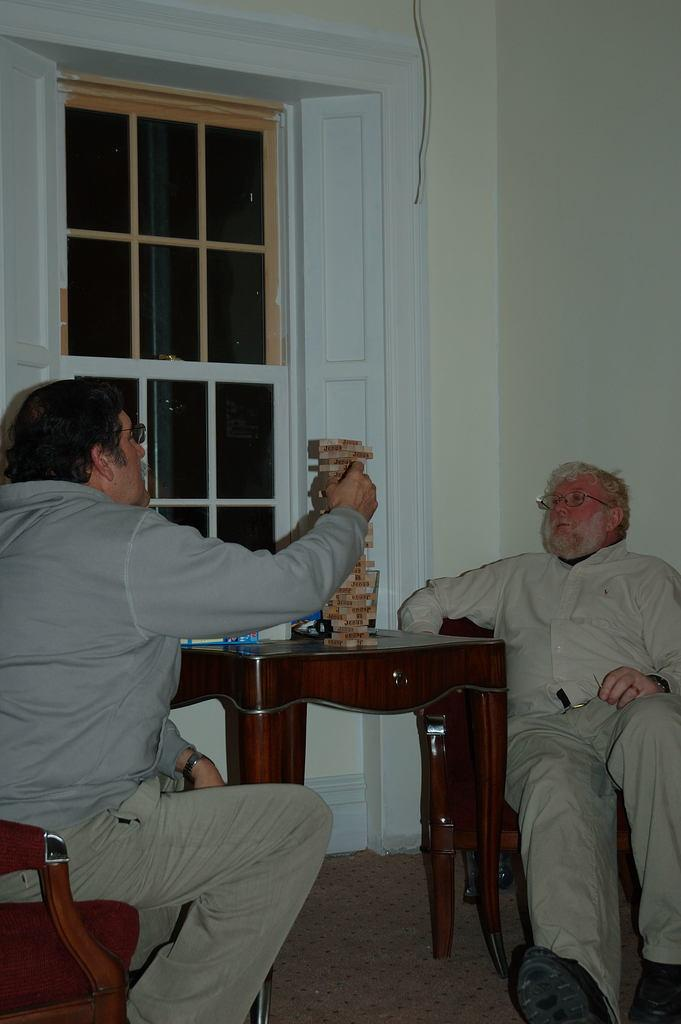How many people are in the image? There are two old men in the image. What are the old men doing in the image? The old men are sitting on chairs. What is in front of the old men? There is a table in front of the old men. What can be seen beside the old men? There is a window beside the old men. What type of bone is visible on the table in the image? There is no bone present on the table in the image. 